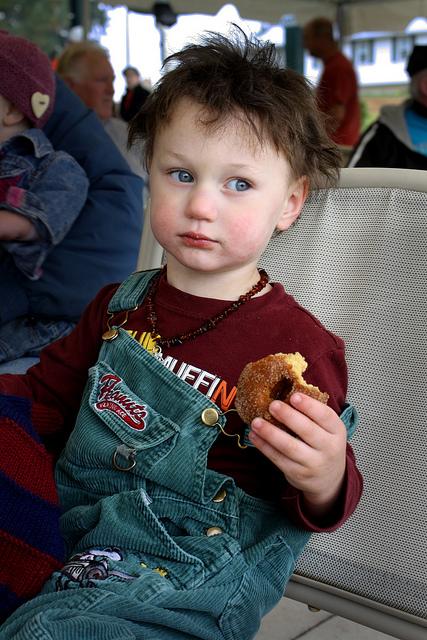What type of furniture is the girl sitting on?
Keep it brief. Chair. What is the little boy holding in his hand?
Give a very brief answer. Donut. What color are his eyes?
Short answer required. Blue. Why is the little boy grinning?
Concise answer only. Eating donut. What is the boy wearing?
Give a very brief answer. Overalls. 